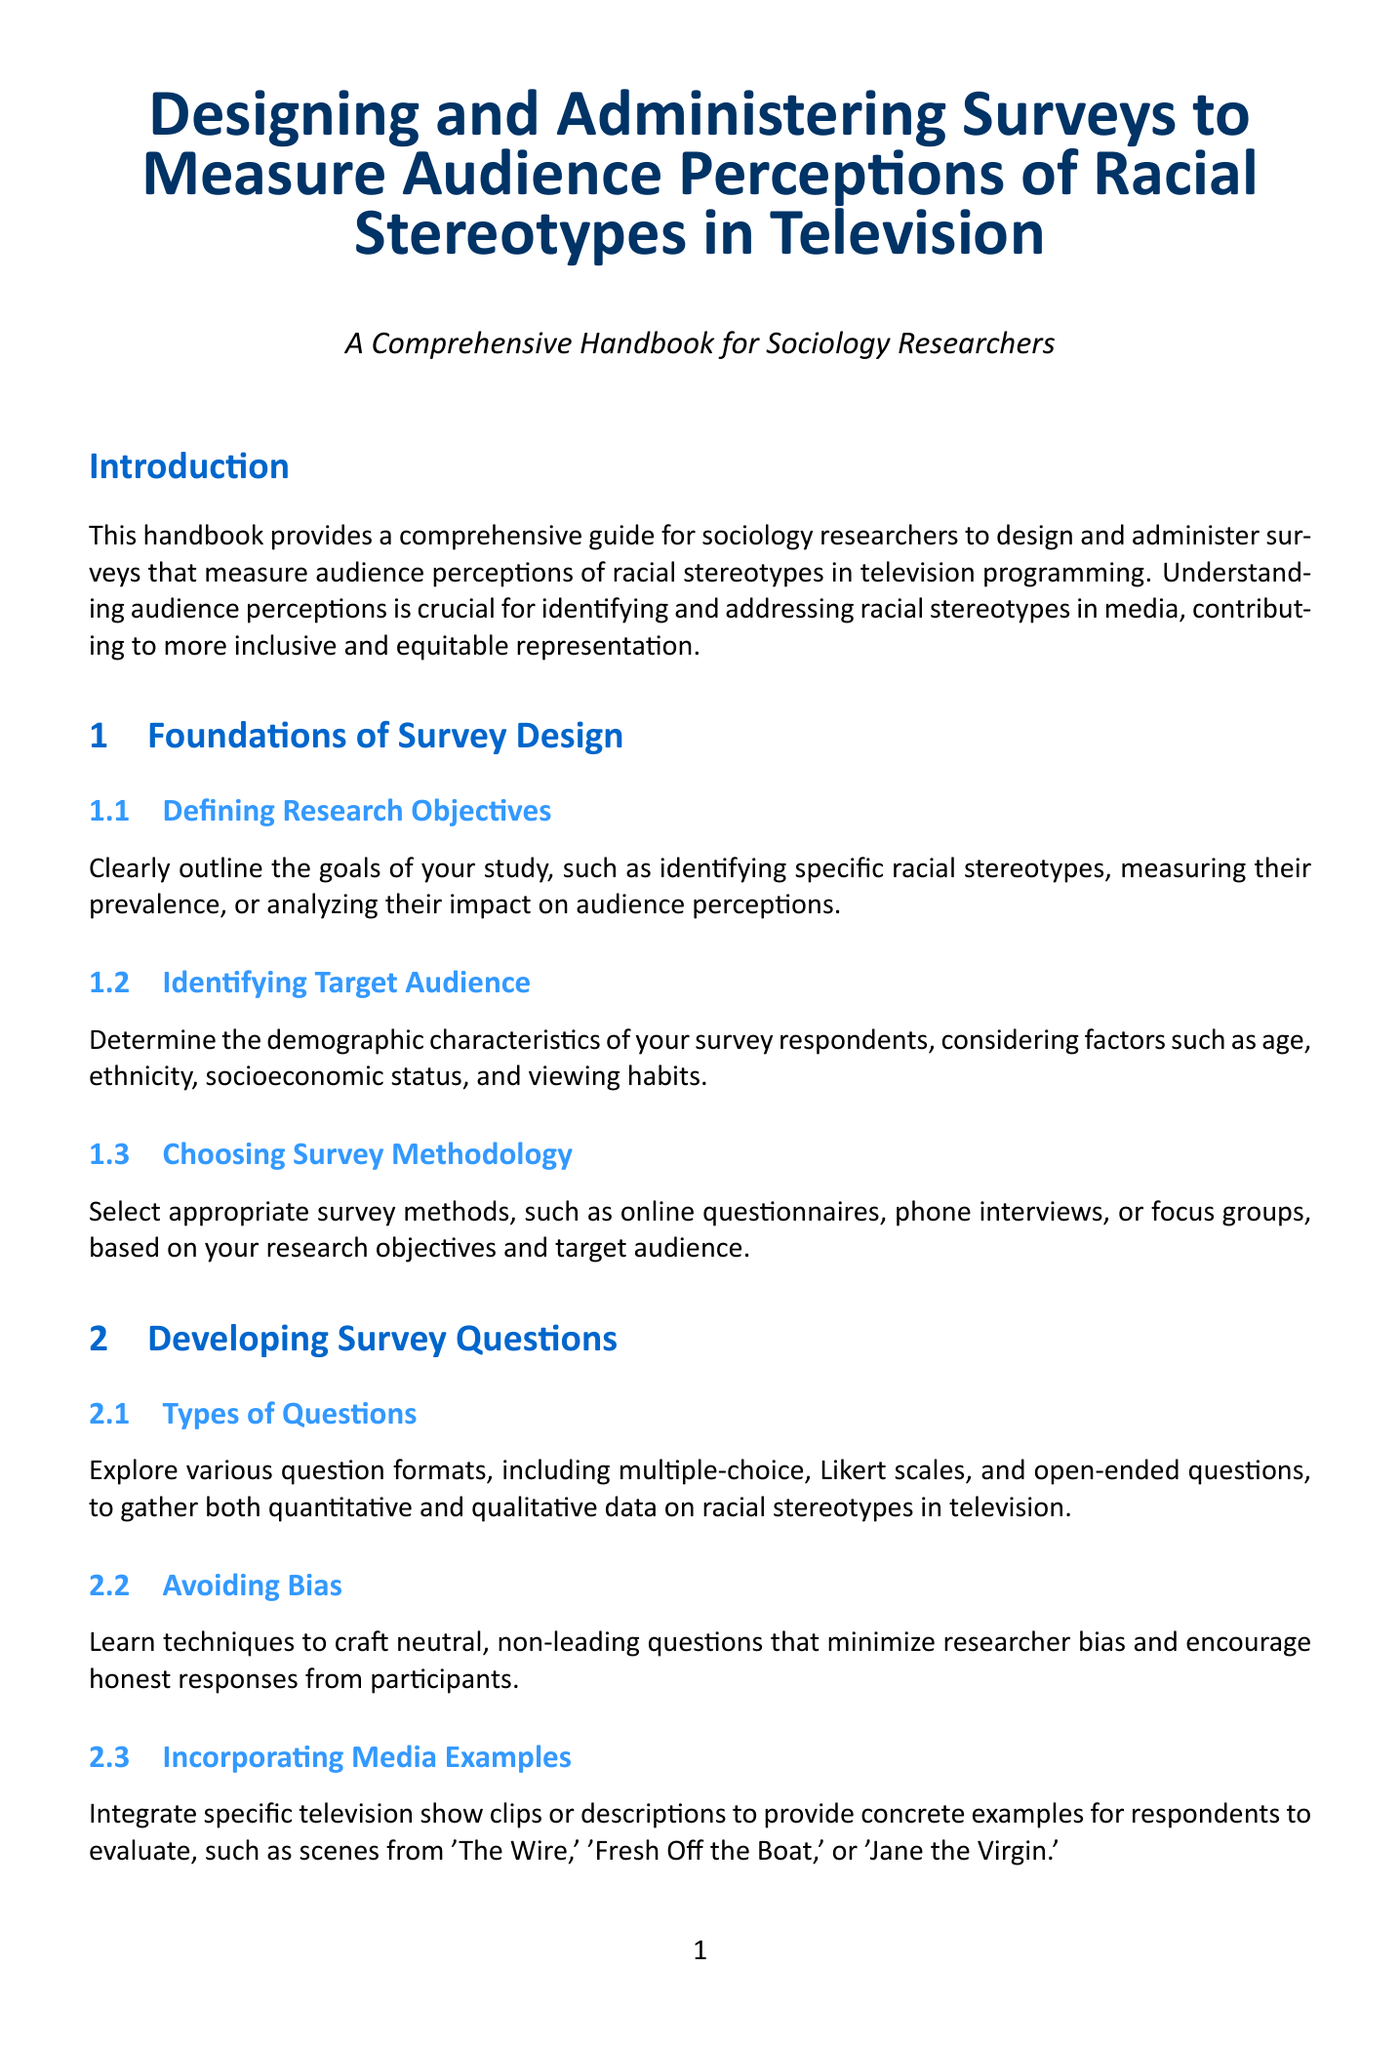what is the title of the handbook? The title is stated in the beginning section of the document and is a comprehensive description of its content.
Answer: Designing and Administering Surveys to Measure Audience Perceptions of Racial Stereotypes in Television what are the three types of sampling methods mentioned? The document explains different sampling techniques under survey administration.
Answer: probability, non-probability, stratified random sampling how long should the survey aim to be completed? The recommended survey completion time is specified to maintain engagement.
Answer: 15-20 minutes what is the purpose of including media examples in the survey? The document explains the significance of integrating media examples within survey questions for clarity.
Answer: provide concrete examples for respondents what is one analytical method mentioned for quantitative analysis? The document lists specific statistical methods for analyzing survey data, providing multiple options.
Answer: chi-square tests which chapter covers ethical considerations? The content on ethical considerations is organized under a specific chapter in the document.
Answer: Chapter 5 how many appendices are included in the document? The document provides a summary of its structure, including appendices at the end.
Answer: 3 what is the focus of Chapter 2? This chapter has a specific aim in guiding the creation of survey questions and formats.
Answer: Developing Survey Questions what is one tool suggested for data visualization? The document lists various tools available for creating data visualizations in research reporting.
Answer: Tableau 